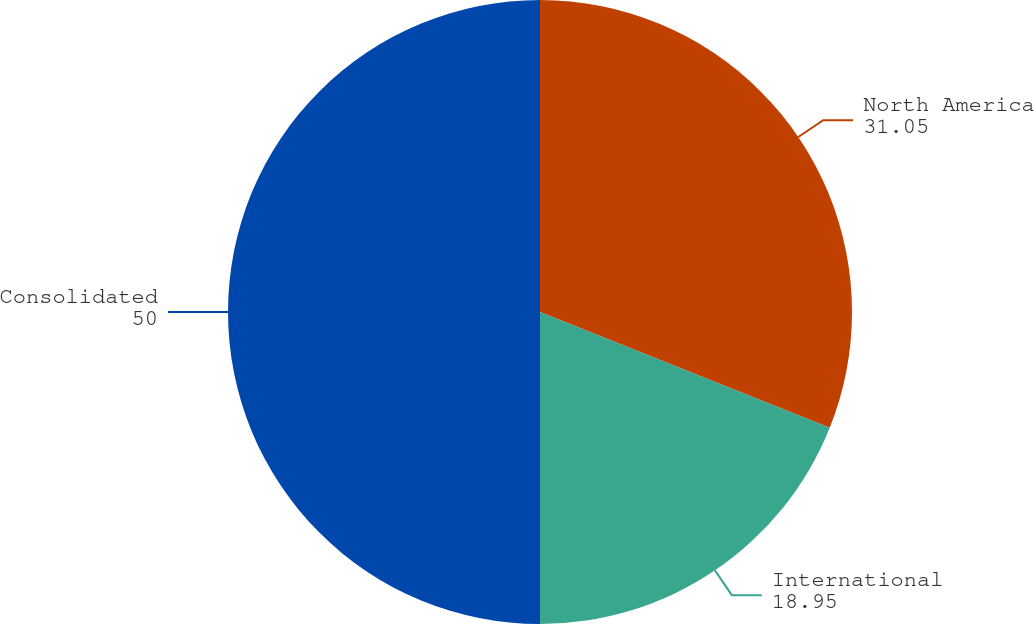<chart> <loc_0><loc_0><loc_500><loc_500><pie_chart><fcel>North America<fcel>International<fcel>Consolidated<nl><fcel>31.05%<fcel>18.95%<fcel>50.0%<nl></chart> 